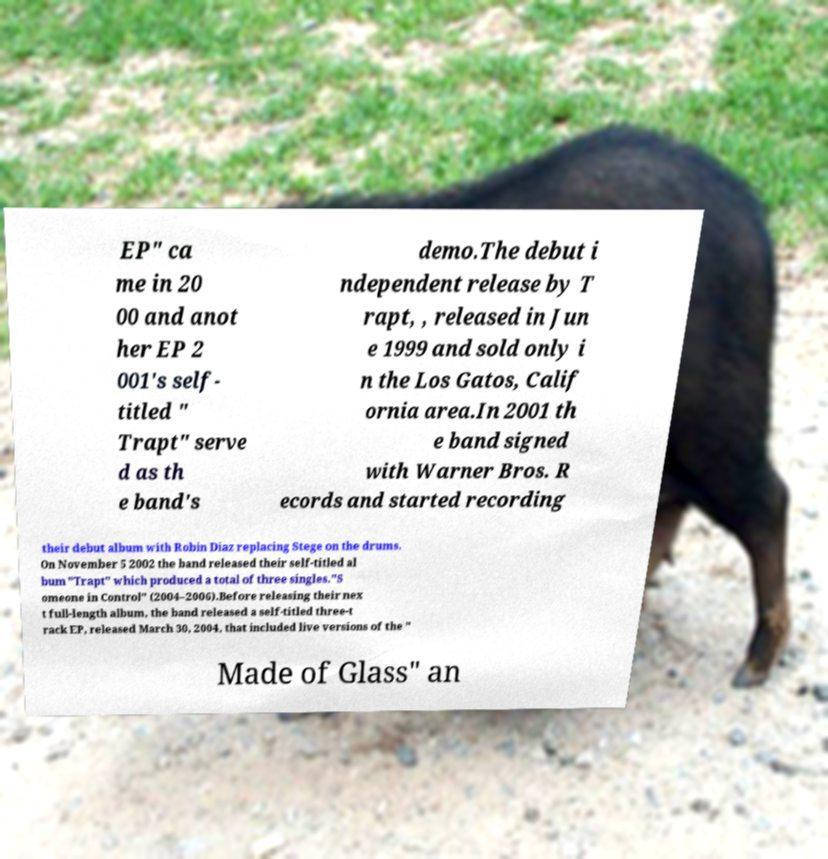Can you read and provide the text displayed in the image?This photo seems to have some interesting text. Can you extract and type it out for me? EP" ca me in 20 00 and anot her EP 2 001's self- titled " Trapt" serve d as th e band's demo.The debut i ndependent release by T rapt, , released in Jun e 1999 and sold only i n the Los Gatos, Calif ornia area.In 2001 th e band signed with Warner Bros. R ecords and started recording their debut album with Robin Diaz replacing Stege on the drums. On November 5 2002 the band released their self-titled al bum "Trapt" which produced a total of three singles."S omeone in Control" (2004–2006).Before releasing their nex t full-length album, the band released a self-titled three-t rack EP, released March 30, 2004, that included live versions of the " Made of Glass" an 